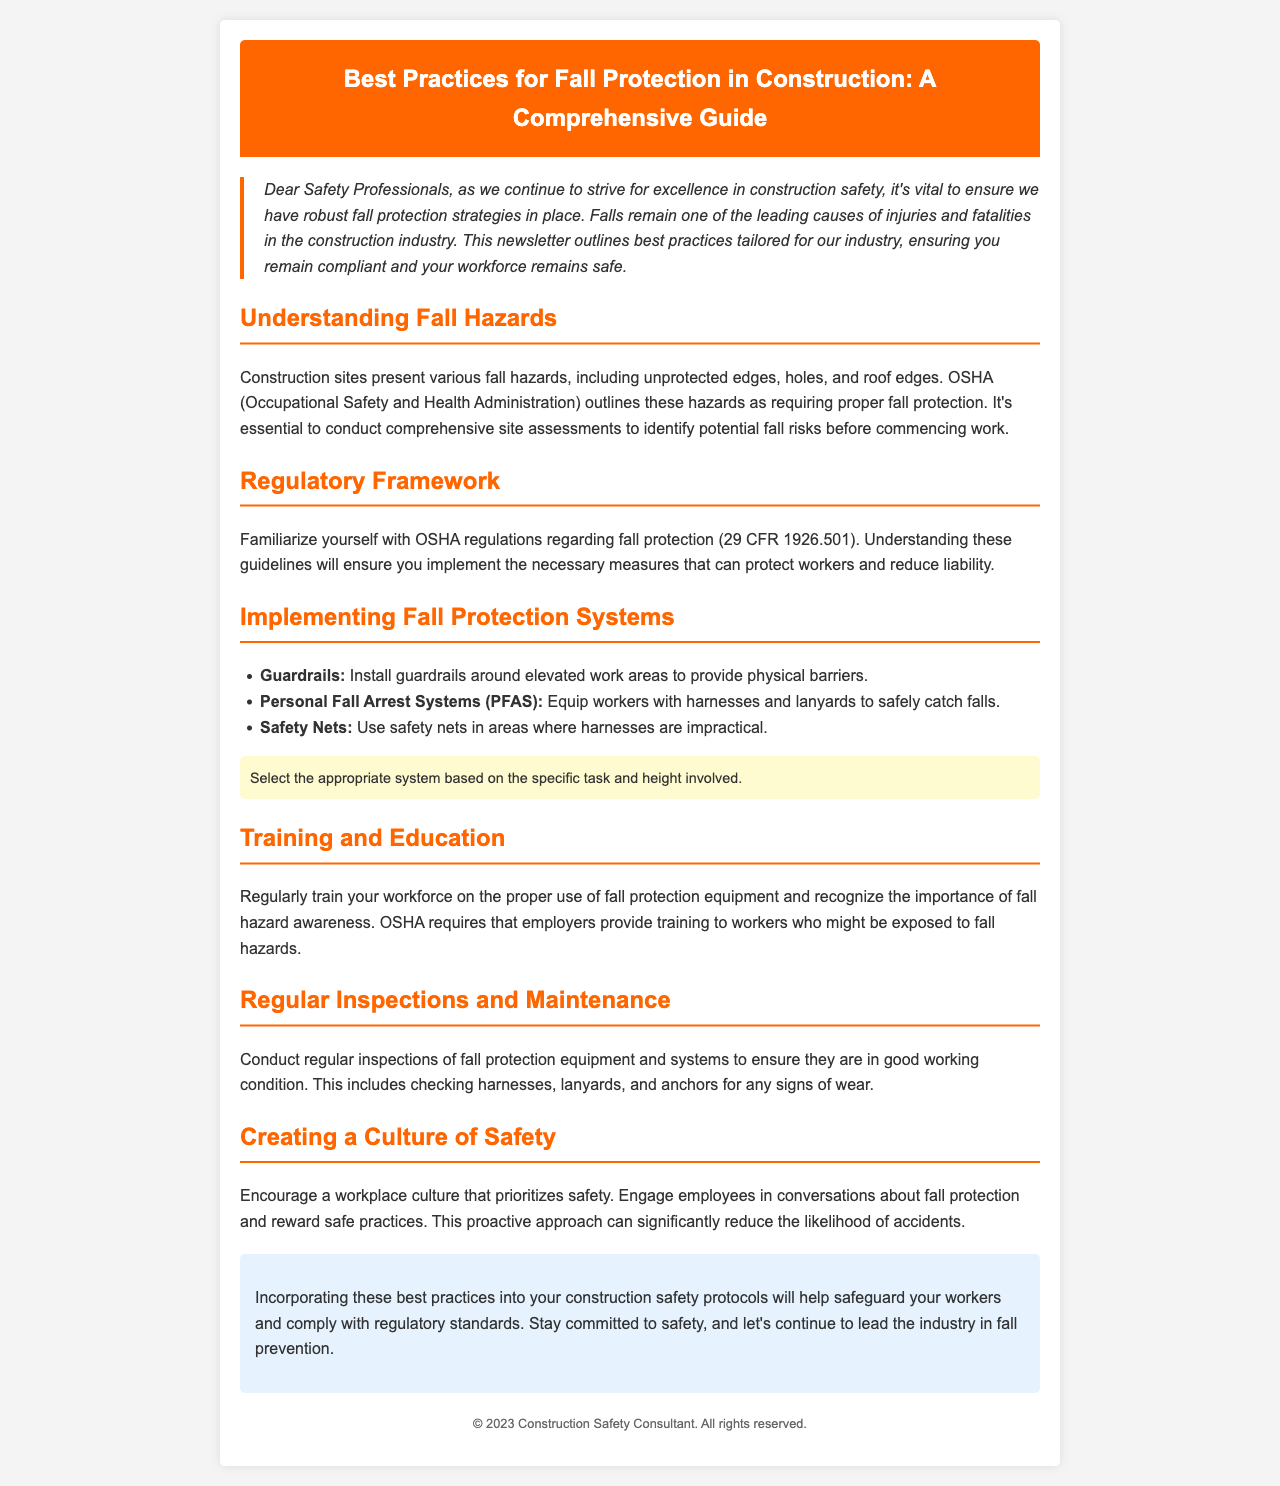What remains one of the leading causes of injuries in construction? Falls are stated as one of the leading causes of injuries and fatalities in the construction industry.
Answer: Falls What does OSHA outline as requiring proper fall protection? OSHA outlines unprotected edges, holes, and roof edges as requiring proper fall protection.
Answer: Unprotected edges, holes, and roof edges What is the OSHA regulation code related to fall protection? The document mentions OSHA regulations regarding fall protection as 29 CFR 1926.501.
Answer: 29 CFR 1926.501 What should be regularly checked for signs of wear? The document states that regular inspections should include checking harnesses, lanyards, and anchors for any signs of wear.
Answer: Harnesses, lanyards, and anchors How can a workplace culture prioritize safety? The document suggests engaging employees in conversations about fall protection and rewarding safe practices.
Answer: Engage employees and reward safe practices What is essential to conduct before commencing work on a construction site? The document emphasizes the need to conduct comprehensive site assessments to identify potential fall risks.
Answer: Comprehensive site assessments What should fall protection systems be based on? The appropriate fall protection system should be based on the specific task and height involved.
Answer: Specific task and height What should be included in the training provided to workers? Regular training on the proper use of fall protection equipment and awareness of fall hazards is required.
Answer: Proper use of equipment and fall hazard awareness 